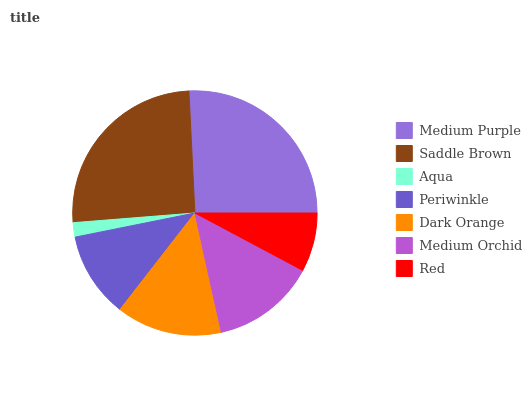Is Aqua the minimum?
Answer yes or no. Yes. Is Medium Purple the maximum?
Answer yes or no. Yes. Is Saddle Brown the minimum?
Answer yes or no. No. Is Saddle Brown the maximum?
Answer yes or no. No. Is Medium Purple greater than Saddle Brown?
Answer yes or no. Yes. Is Saddle Brown less than Medium Purple?
Answer yes or no. Yes. Is Saddle Brown greater than Medium Purple?
Answer yes or no. No. Is Medium Purple less than Saddle Brown?
Answer yes or no. No. Is Medium Orchid the high median?
Answer yes or no. Yes. Is Medium Orchid the low median?
Answer yes or no. Yes. Is Saddle Brown the high median?
Answer yes or no. No. Is Dark Orange the low median?
Answer yes or no. No. 